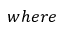<formula> <loc_0><loc_0><loc_500><loc_500>w h e r e</formula> 